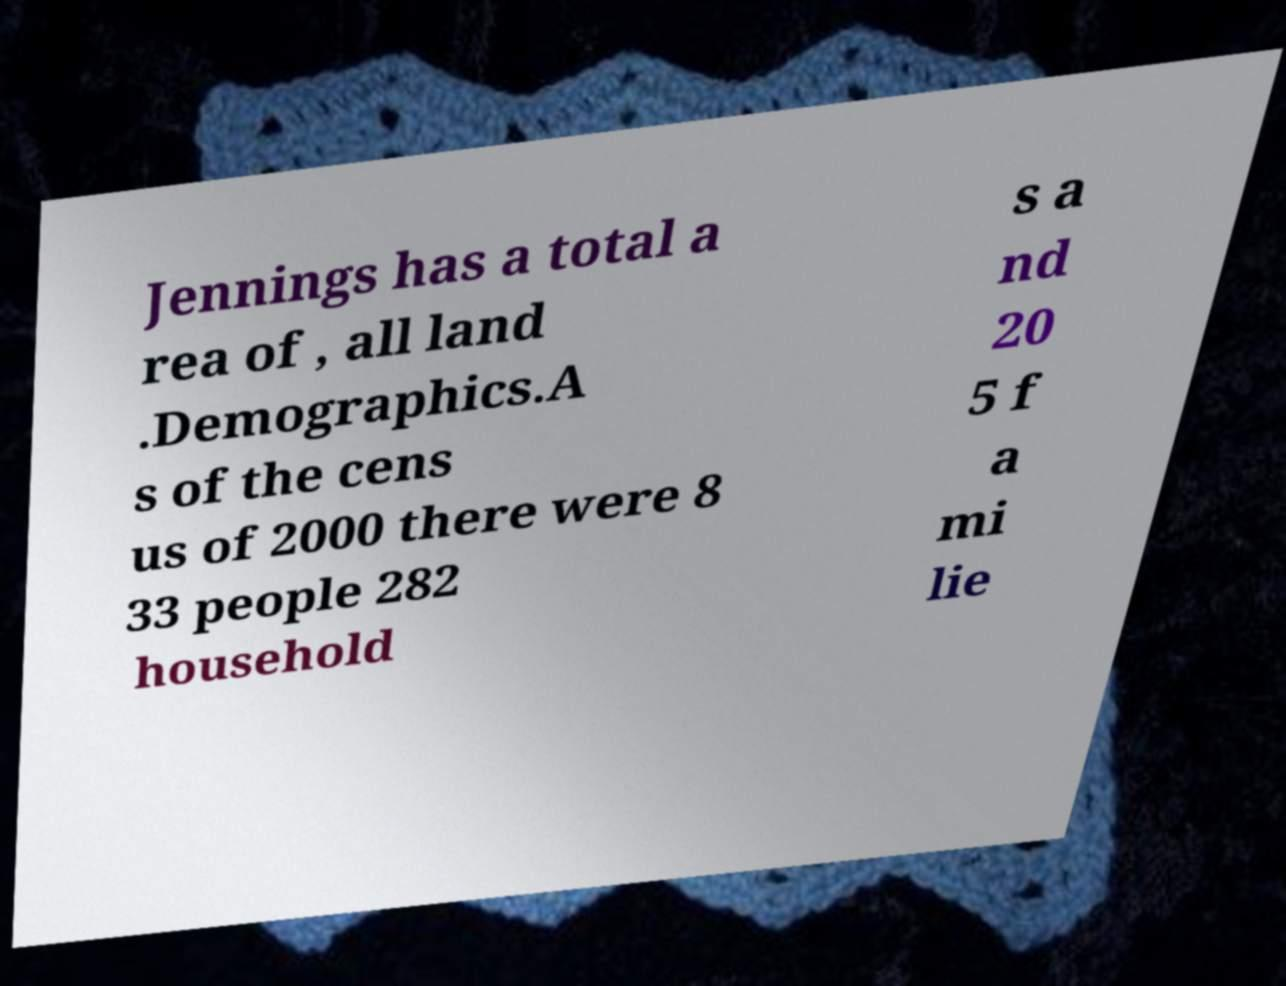For documentation purposes, I need the text within this image transcribed. Could you provide that? Jennings has a total a rea of , all land .Demographics.A s of the cens us of 2000 there were 8 33 people 282 household s a nd 20 5 f a mi lie 